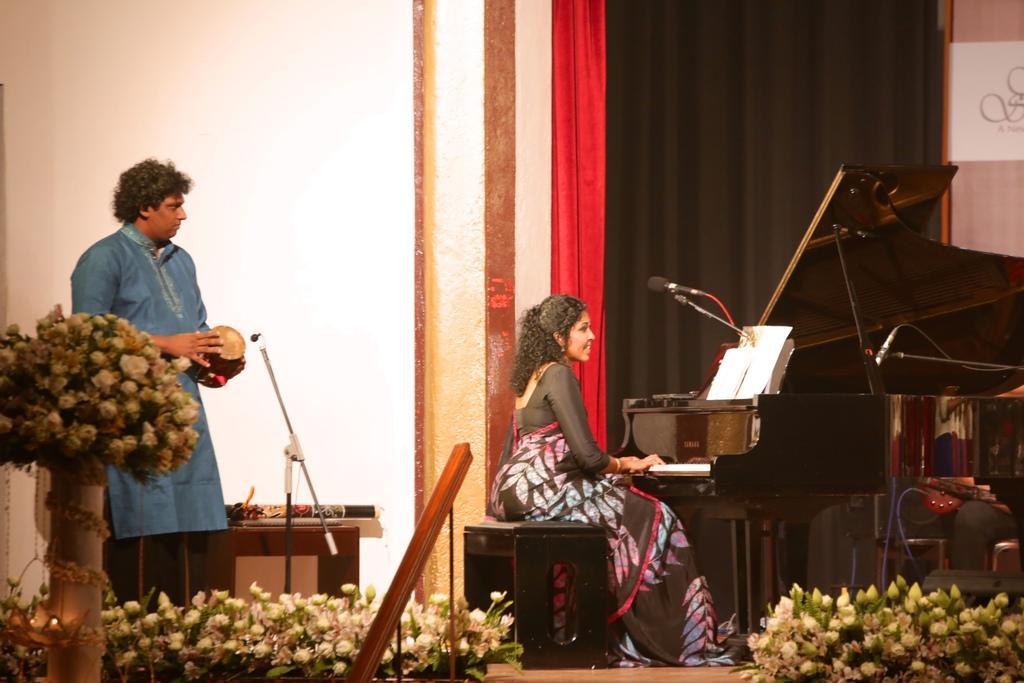Describe this image in one or two sentences. a person is sitting on the left and playing keyboard. up on it there is a paper and a microphone. she is wearing a black saree. at the left a person is standing and playing drum, is wearing a blue dress. at the right back there are black and red curtains. at the left back there is a wall. in the front there are white flowers. 